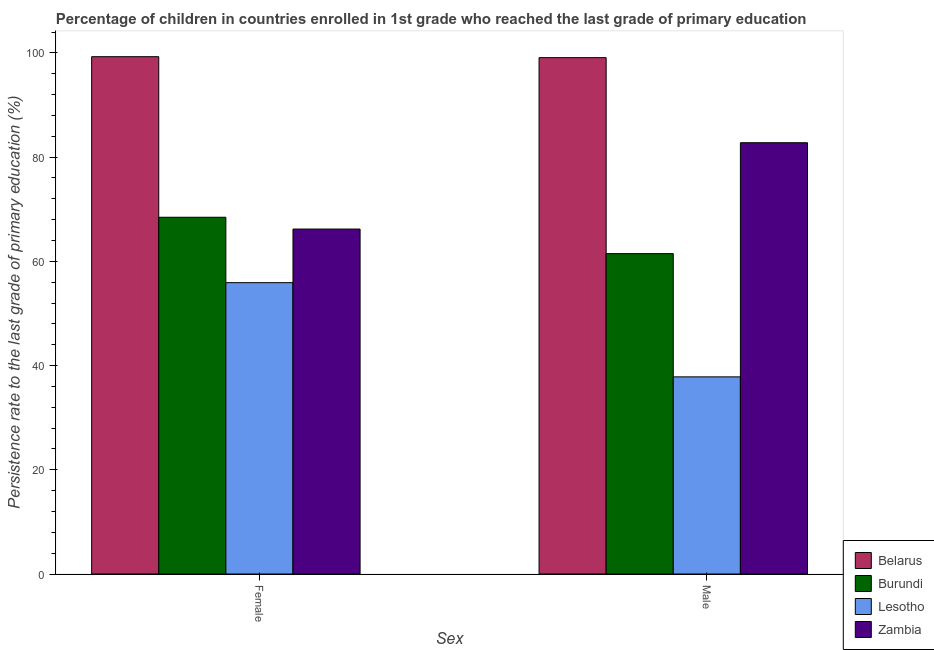How many different coloured bars are there?
Ensure brevity in your answer.  4. Are the number of bars on each tick of the X-axis equal?
Offer a terse response. Yes. How many bars are there on the 1st tick from the left?
Ensure brevity in your answer.  4. How many bars are there on the 1st tick from the right?
Ensure brevity in your answer.  4. What is the persistence rate of male students in Burundi?
Provide a short and direct response. 61.47. Across all countries, what is the maximum persistence rate of female students?
Give a very brief answer. 99.26. Across all countries, what is the minimum persistence rate of male students?
Give a very brief answer. 37.83. In which country was the persistence rate of male students maximum?
Make the answer very short. Belarus. In which country was the persistence rate of male students minimum?
Your answer should be very brief. Lesotho. What is the total persistence rate of female students in the graph?
Offer a very short reply. 289.81. What is the difference between the persistence rate of female students in Burundi and that in Lesotho?
Offer a very short reply. 12.55. What is the difference between the persistence rate of male students in Lesotho and the persistence rate of female students in Burundi?
Offer a terse response. -30.63. What is the average persistence rate of female students per country?
Provide a succinct answer. 72.45. What is the difference between the persistence rate of female students and persistence rate of male students in Lesotho?
Your answer should be compact. 18.08. In how many countries, is the persistence rate of female students greater than 32 %?
Give a very brief answer. 4. What is the ratio of the persistence rate of female students in Zambia to that in Belarus?
Make the answer very short. 0.67. Is the persistence rate of male students in Lesotho less than that in Burundi?
Give a very brief answer. Yes. What does the 3rd bar from the left in Female represents?
Keep it short and to the point. Lesotho. What does the 4th bar from the right in Male represents?
Offer a very short reply. Belarus. What is the difference between two consecutive major ticks on the Y-axis?
Your answer should be compact. 20. Does the graph contain grids?
Ensure brevity in your answer.  No. Where does the legend appear in the graph?
Provide a short and direct response. Bottom right. How many legend labels are there?
Your answer should be compact. 4. What is the title of the graph?
Your answer should be compact. Percentage of children in countries enrolled in 1st grade who reached the last grade of primary education. Does "Pakistan" appear as one of the legend labels in the graph?
Make the answer very short. No. What is the label or title of the X-axis?
Provide a short and direct response. Sex. What is the label or title of the Y-axis?
Offer a very short reply. Persistence rate to the last grade of primary education (%). What is the Persistence rate to the last grade of primary education (%) in Belarus in Female?
Your answer should be very brief. 99.26. What is the Persistence rate to the last grade of primary education (%) in Burundi in Female?
Offer a very short reply. 68.45. What is the Persistence rate to the last grade of primary education (%) in Lesotho in Female?
Your answer should be very brief. 55.9. What is the Persistence rate to the last grade of primary education (%) in Zambia in Female?
Your answer should be very brief. 66.19. What is the Persistence rate to the last grade of primary education (%) in Belarus in Male?
Give a very brief answer. 99.08. What is the Persistence rate to the last grade of primary education (%) of Burundi in Male?
Offer a very short reply. 61.47. What is the Persistence rate to the last grade of primary education (%) in Lesotho in Male?
Your answer should be very brief. 37.83. What is the Persistence rate to the last grade of primary education (%) of Zambia in Male?
Your answer should be very brief. 82.75. Across all Sex, what is the maximum Persistence rate to the last grade of primary education (%) in Belarus?
Ensure brevity in your answer.  99.26. Across all Sex, what is the maximum Persistence rate to the last grade of primary education (%) in Burundi?
Give a very brief answer. 68.45. Across all Sex, what is the maximum Persistence rate to the last grade of primary education (%) in Lesotho?
Give a very brief answer. 55.9. Across all Sex, what is the maximum Persistence rate to the last grade of primary education (%) of Zambia?
Ensure brevity in your answer.  82.75. Across all Sex, what is the minimum Persistence rate to the last grade of primary education (%) of Belarus?
Ensure brevity in your answer.  99.08. Across all Sex, what is the minimum Persistence rate to the last grade of primary education (%) in Burundi?
Keep it short and to the point. 61.47. Across all Sex, what is the minimum Persistence rate to the last grade of primary education (%) in Lesotho?
Offer a very short reply. 37.83. Across all Sex, what is the minimum Persistence rate to the last grade of primary education (%) in Zambia?
Your response must be concise. 66.19. What is the total Persistence rate to the last grade of primary education (%) of Belarus in the graph?
Provide a succinct answer. 198.34. What is the total Persistence rate to the last grade of primary education (%) in Burundi in the graph?
Offer a terse response. 129.93. What is the total Persistence rate to the last grade of primary education (%) of Lesotho in the graph?
Your answer should be compact. 93.73. What is the total Persistence rate to the last grade of primary education (%) in Zambia in the graph?
Provide a succinct answer. 148.95. What is the difference between the Persistence rate to the last grade of primary education (%) in Belarus in Female and that in Male?
Make the answer very short. 0.18. What is the difference between the Persistence rate to the last grade of primary education (%) in Burundi in Female and that in Male?
Offer a very short reply. 6.98. What is the difference between the Persistence rate to the last grade of primary education (%) in Lesotho in Female and that in Male?
Offer a terse response. 18.08. What is the difference between the Persistence rate to the last grade of primary education (%) of Zambia in Female and that in Male?
Your answer should be very brief. -16.56. What is the difference between the Persistence rate to the last grade of primary education (%) in Belarus in Female and the Persistence rate to the last grade of primary education (%) in Burundi in Male?
Give a very brief answer. 37.79. What is the difference between the Persistence rate to the last grade of primary education (%) in Belarus in Female and the Persistence rate to the last grade of primary education (%) in Lesotho in Male?
Your answer should be compact. 61.44. What is the difference between the Persistence rate to the last grade of primary education (%) in Belarus in Female and the Persistence rate to the last grade of primary education (%) in Zambia in Male?
Provide a succinct answer. 16.51. What is the difference between the Persistence rate to the last grade of primary education (%) of Burundi in Female and the Persistence rate to the last grade of primary education (%) of Lesotho in Male?
Offer a terse response. 30.63. What is the difference between the Persistence rate to the last grade of primary education (%) in Burundi in Female and the Persistence rate to the last grade of primary education (%) in Zambia in Male?
Give a very brief answer. -14.3. What is the difference between the Persistence rate to the last grade of primary education (%) of Lesotho in Female and the Persistence rate to the last grade of primary education (%) of Zambia in Male?
Give a very brief answer. -26.85. What is the average Persistence rate to the last grade of primary education (%) in Belarus per Sex?
Your response must be concise. 99.17. What is the average Persistence rate to the last grade of primary education (%) in Burundi per Sex?
Provide a short and direct response. 64.96. What is the average Persistence rate to the last grade of primary education (%) in Lesotho per Sex?
Your response must be concise. 46.86. What is the average Persistence rate to the last grade of primary education (%) in Zambia per Sex?
Make the answer very short. 74.47. What is the difference between the Persistence rate to the last grade of primary education (%) of Belarus and Persistence rate to the last grade of primary education (%) of Burundi in Female?
Make the answer very short. 30.81. What is the difference between the Persistence rate to the last grade of primary education (%) of Belarus and Persistence rate to the last grade of primary education (%) of Lesotho in Female?
Ensure brevity in your answer.  43.36. What is the difference between the Persistence rate to the last grade of primary education (%) in Belarus and Persistence rate to the last grade of primary education (%) in Zambia in Female?
Your response must be concise. 33.07. What is the difference between the Persistence rate to the last grade of primary education (%) in Burundi and Persistence rate to the last grade of primary education (%) in Lesotho in Female?
Offer a very short reply. 12.55. What is the difference between the Persistence rate to the last grade of primary education (%) of Burundi and Persistence rate to the last grade of primary education (%) of Zambia in Female?
Provide a succinct answer. 2.26. What is the difference between the Persistence rate to the last grade of primary education (%) of Lesotho and Persistence rate to the last grade of primary education (%) of Zambia in Female?
Ensure brevity in your answer.  -10.29. What is the difference between the Persistence rate to the last grade of primary education (%) in Belarus and Persistence rate to the last grade of primary education (%) in Burundi in Male?
Make the answer very short. 37.61. What is the difference between the Persistence rate to the last grade of primary education (%) in Belarus and Persistence rate to the last grade of primary education (%) in Lesotho in Male?
Make the answer very short. 61.25. What is the difference between the Persistence rate to the last grade of primary education (%) of Belarus and Persistence rate to the last grade of primary education (%) of Zambia in Male?
Offer a terse response. 16.32. What is the difference between the Persistence rate to the last grade of primary education (%) in Burundi and Persistence rate to the last grade of primary education (%) in Lesotho in Male?
Offer a very short reply. 23.65. What is the difference between the Persistence rate to the last grade of primary education (%) in Burundi and Persistence rate to the last grade of primary education (%) in Zambia in Male?
Offer a very short reply. -21.28. What is the difference between the Persistence rate to the last grade of primary education (%) in Lesotho and Persistence rate to the last grade of primary education (%) in Zambia in Male?
Offer a very short reply. -44.93. What is the ratio of the Persistence rate to the last grade of primary education (%) in Belarus in Female to that in Male?
Your response must be concise. 1. What is the ratio of the Persistence rate to the last grade of primary education (%) of Burundi in Female to that in Male?
Offer a very short reply. 1.11. What is the ratio of the Persistence rate to the last grade of primary education (%) of Lesotho in Female to that in Male?
Your answer should be very brief. 1.48. What is the ratio of the Persistence rate to the last grade of primary education (%) of Zambia in Female to that in Male?
Your response must be concise. 0.8. What is the difference between the highest and the second highest Persistence rate to the last grade of primary education (%) of Belarus?
Offer a very short reply. 0.18. What is the difference between the highest and the second highest Persistence rate to the last grade of primary education (%) of Burundi?
Give a very brief answer. 6.98. What is the difference between the highest and the second highest Persistence rate to the last grade of primary education (%) of Lesotho?
Give a very brief answer. 18.08. What is the difference between the highest and the second highest Persistence rate to the last grade of primary education (%) in Zambia?
Ensure brevity in your answer.  16.56. What is the difference between the highest and the lowest Persistence rate to the last grade of primary education (%) of Belarus?
Your response must be concise. 0.18. What is the difference between the highest and the lowest Persistence rate to the last grade of primary education (%) in Burundi?
Offer a very short reply. 6.98. What is the difference between the highest and the lowest Persistence rate to the last grade of primary education (%) in Lesotho?
Your response must be concise. 18.08. What is the difference between the highest and the lowest Persistence rate to the last grade of primary education (%) in Zambia?
Keep it short and to the point. 16.56. 